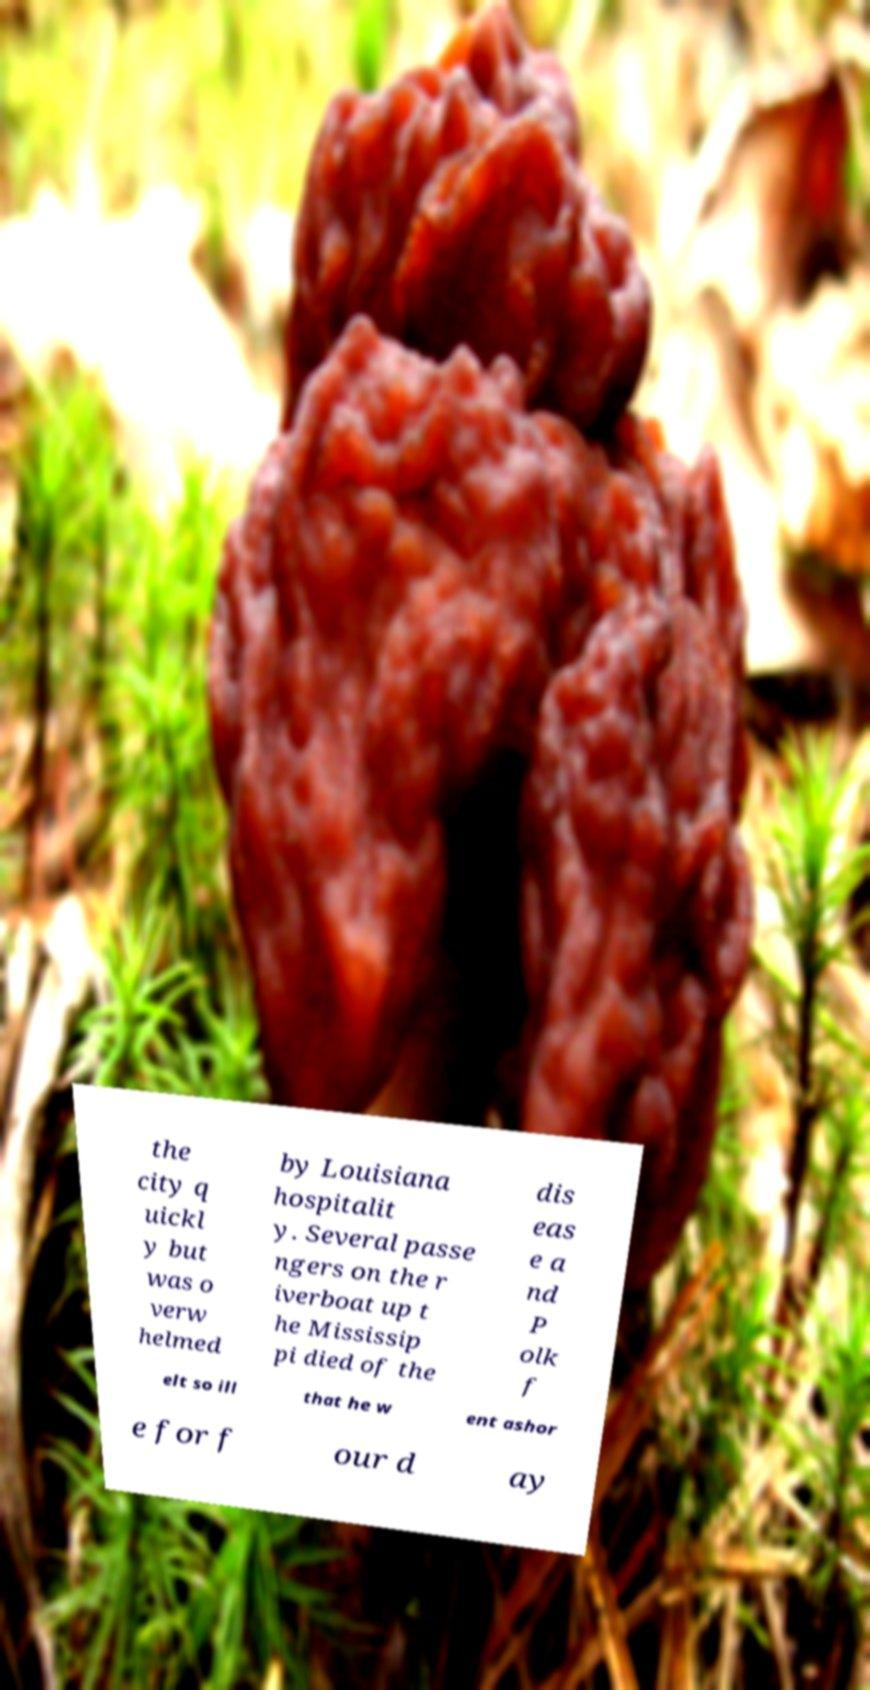Could you extract and type out the text from this image? the city q uickl y but was o verw helmed by Louisiana hospitalit y. Several passe ngers on the r iverboat up t he Mississip pi died of the dis eas e a nd P olk f elt so ill that he w ent ashor e for f our d ay 